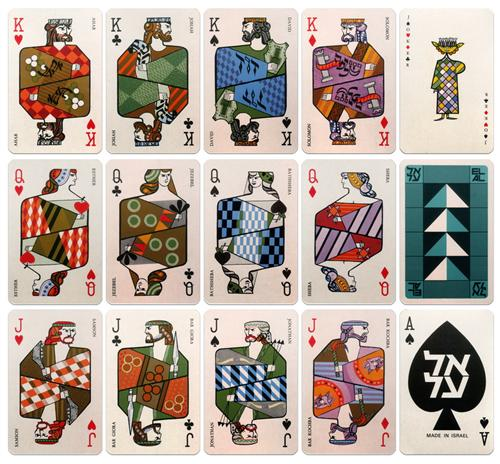Explain the visual content of the image in great detail. The image showcases a vibrant set of playing cards, each distinctively adorned with mid-century modern art designs. The cards are laid out in an organized grid pattern, with each row representing different face cards—kings on the first row, queens on the second, and jacks on the last. The visual style of these cards features geometric patterns, a stark contrast of colors, and a clear influence of mid-century modern aesthetics notable for its emphasis on simplicity and functionality. While maintaining a minimalist approach, the patterns entail a complex interaction of shapes that provide a sense of depth. The artwork on the cards not only enhances their visual appeal but also reflects a fusion of classical card elements with modern artistic expression. This design choice might reflect the era's cultural shift towards more abstract and stylized forms in everyday objects, possibly attempting to blend traditional card games with contemporary art trends. 